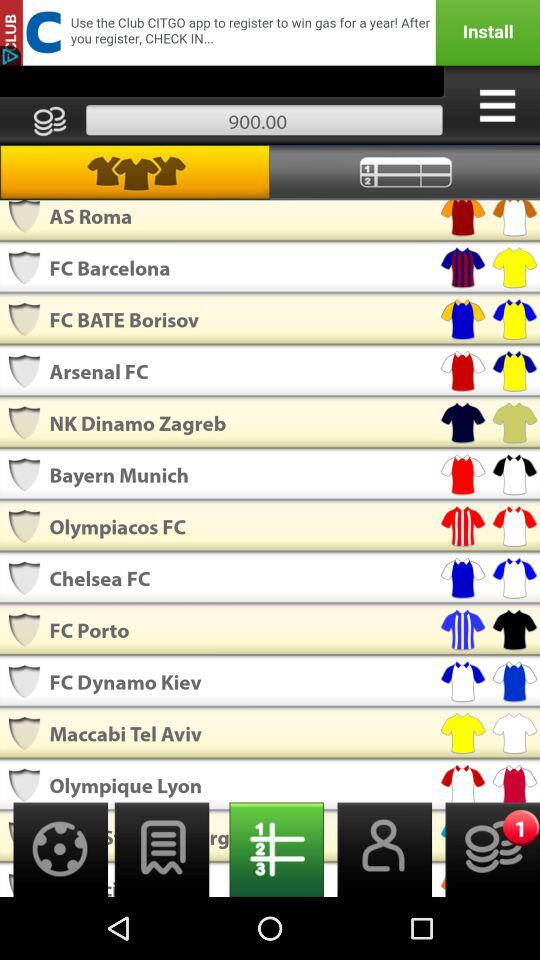What is the given number of coins? The screenshot displays that the number of coins is 900. This number may likely reflect a balance or score in the context of a mobile application, commonly used in games or reward-based platforms for tracking progress or purchasing virtual goods. 